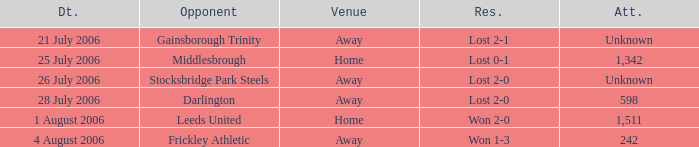What is the result from the Leeds United opponent? Won 2-0. 